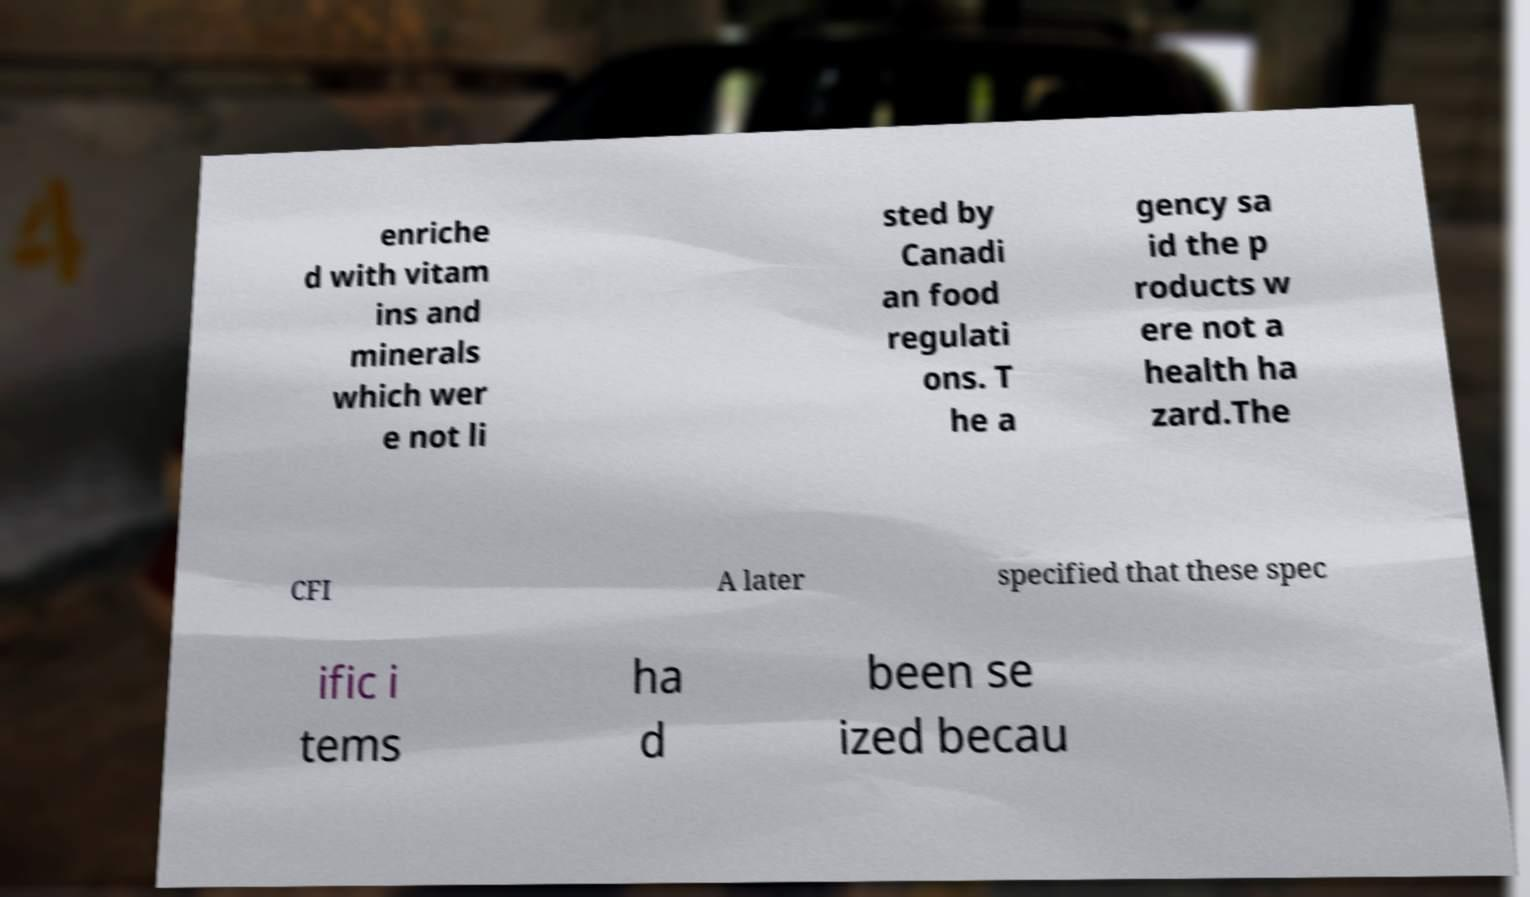Can you accurately transcribe the text from the provided image for me? enriche d with vitam ins and minerals which wer e not li sted by Canadi an food regulati ons. T he a gency sa id the p roducts w ere not a health ha zard.The CFI A later specified that these spec ific i tems ha d been se ized becau 